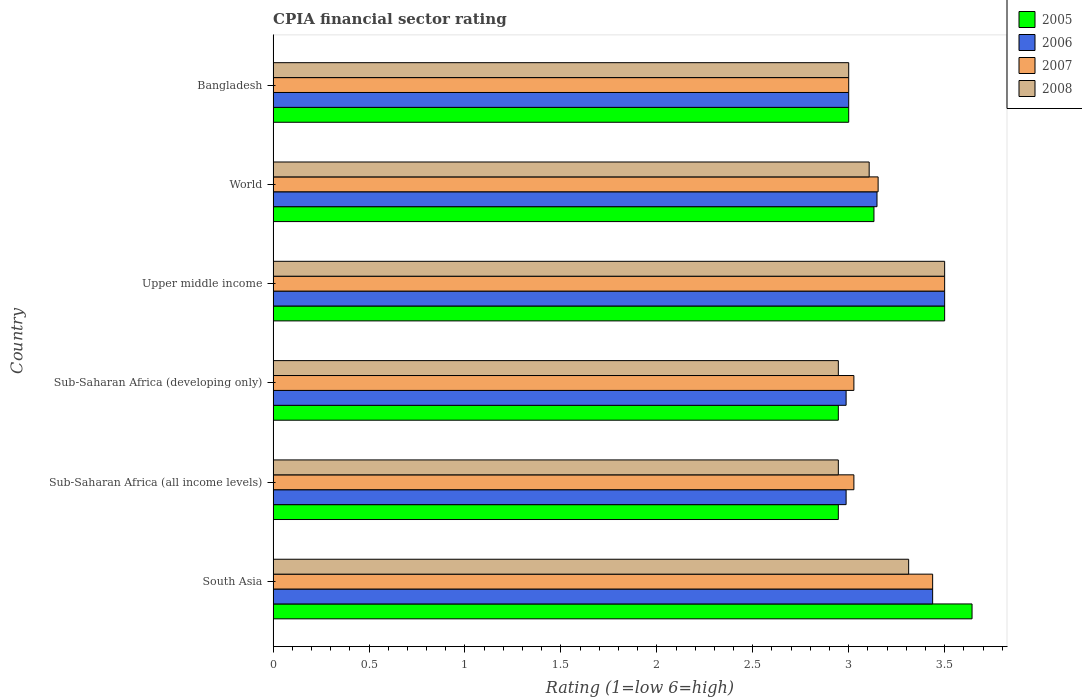How many different coloured bars are there?
Give a very brief answer. 4. How many groups of bars are there?
Your answer should be compact. 6. Are the number of bars per tick equal to the number of legend labels?
Give a very brief answer. Yes. Are the number of bars on each tick of the Y-axis equal?
Provide a succinct answer. Yes. How many bars are there on the 5th tick from the bottom?
Make the answer very short. 4. What is the label of the 5th group of bars from the top?
Ensure brevity in your answer.  Sub-Saharan Africa (all income levels). In how many cases, is the number of bars for a given country not equal to the number of legend labels?
Offer a terse response. 0. What is the CPIA rating in 2008 in Sub-Saharan Africa (all income levels)?
Offer a terse response. 2.95. Across all countries, what is the minimum CPIA rating in 2008?
Offer a very short reply. 2.95. In which country was the CPIA rating in 2008 minimum?
Provide a succinct answer. Sub-Saharan Africa (all income levels). What is the total CPIA rating in 2005 in the graph?
Make the answer very short. 19.17. What is the difference between the CPIA rating in 2005 in Upper middle income and that in World?
Give a very brief answer. 0.37. What is the difference between the CPIA rating in 2005 in Bangladesh and the CPIA rating in 2006 in World?
Make the answer very short. -0.15. What is the average CPIA rating in 2008 per country?
Give a very brief answer. 3.14. What is the difference between the CPIA rating in 2006 and CPIA rating in 2008 in Bangladesh?
Offer a terse response. 0. What is the ratio of the CPIA rating in 2008 in South Asia to that in Sub-Saharan Africa (developing only)?
Keep it short and to the point. 1.12. Is the CPIA rating in 2006 in South Asia less than that in World?
Provide a short and direct response. No. Is the difference between the CPIA rating in 2006 in Sub-Saharan Africa (developing only) and Upper middle income greater than the difference between the CPIA rating in 2008 in Sub-Saharan Africa (developing only) and Upper middle income?
Make the answer very short. Yes. What is the difference between the highest and the second highest CPIA rating in 2007?
Your answer should be compact. 0.06. What is the difference between the highest and the lowest CPIA rating in 2006?
Your answer should be compact. 0.51. In how many countries, is the CPIA rating in 2008 greater than the average CPIA rating in 2008 taken over all countries?
Provide a succinct answer. 2. Is the sum of the CPIA rating in 2006 in Sub-Saharan Africa (all income levels) and Upper middle income greater than the maximum CPIA rating in 2005 across all countries?
Your answer should be very brief. Yes. What does the 1st bar from the top in South Asia represents?
Provide a succinct answer. 2008. Is it the case that in every country, the sum of the CPIA rating in 2007 and CPIA rating in 2008 is greater than the CPIA rating in 2006?
Offer a very short reply. Yes. Are all the bars in the graph horizontal?
Ensure brevity in your answer.  Yes. What is the difference between two consecutive major ticks on the X-axis?
Your response must be concise. 0.5. Does the graph contain any zero values?
Provide a succinct answer. No. How are the legend labels stacked?
Ensure brevity in your answer.  Vertical. What is the title of the graph?
Ensure brevity in your answer.  CPIA financial sector rating. What is the label or title of the X-axis?
Provide a short and direct response. Rating (1=low 6=high). What is the Rating (1=low 6=high) of 2005 in South Asia?
Ensure brevity in your answer.  3.64. What is the Rating (1=low 6=high) of 2006 in South Asia?
Give a very brief answer. 3.44. What is the Rating (1=low 6=high) of 2007 in South Asia?
Your response must be concise. 3.44. What is the Rating (1=low 6=high) of 2008 in South Asia?
Make the answer very short. 3.31. What is the Rating (1=low 6=high) in 2005 in Sub-Saharan Africa (all income levels)?
Make the answer very short. 2.95. What is the Rating (1=low 6=high) of 2006 in Sub-Saharan Africa (all income levels)?
Your answer should be very brief. 2.99. What is the Rating (1=low 6=high) of 2007 in Sub-Saharan Africa (all income levels)?
Your answer should be compact. 3.03. What is the Rating (1=low 6=high) of 2008 in Sub-Saharan Africa (all income levels)?
Offer a terse response. 2.95. What is the Rating (1=low 6=high) in 2005 in Sub-Saharan Africa (developing only)?
Ensure brevity in your answer.  2.95. What is the Rating (1=low 6=high) in 2006 in Sub-Saharan Africa (developing only)?
Provide a succinct answer. 2.99. What is the Rating (1=low 6=high) in 2007 in Sub-Saharan Africa (developing only)?
Keep it short and to the point. 3.03. What is the Rating (1=low 6=high) in 2008 in Sub-Saharan Africa (developing only)?
Keep it short and to the point. 2.95. What is the Rating (1=low 6=high) of 2005 in World?
Your answer should be very brief. 3.13. What is the Rating (1=low 6=high) in 2006 in World?
Give a very brief answer. 3.15. What is the Rating (1=low 6=high) of 2007 in World?
Give a very brief answer. 3.15. What is the Rating (1=low 6=high) of 2008 in World?
Provide a short and direct response. 3.11. What is the Rating (1=low 6=high) of 2006 in Bangladesh?
Make the answer very short. 3. What is the Rating (1=low 6=high) of 2007 in Bangladesh?
Your response must be concise. 3. What is the Rating (1=low 6=high) in 2008 in Bangladesh?
Keep it short and to the point. 3. Across all countries, what is the maximum Rating (1=low 6=high) of 2005?
Give a very brief answer. 3.64. Across all countries, what is the maximum Rating (1=low 6=high) in 2008?
Offer a very short reply. 3.5. Across all countries, what is the minimum Rating (1=low 6=high) in 2005?
Provide a succinct answer. 2.95. Across all countries, what is the minimum Rating (1=low 6=high) of 2006?
Your response must be concise. 2.99. Across all countries, what is the minimum Rating (1=low 6=high) in 2008?
Give a very brief answer. 2.95. What is the total Rating (1=low 6=high) in 2005 in the graph?
Offer a terse response. 19.17. What is the total Rating (1=low 6=high) in 2006 in the graph?
Offer a very short reply. 19.06. What is the total Rating (1=low 6=high) of 2007 in the graph?
Your answer should be very brief. 19.14. What is the total Rating (1=low 6=high) in 2008 in the graph?
Provide a succinct answer. 18.81. What is the difference between the Rating (1=low 6=high) of 2005 in South Asia and that in Sub-Saharan Africa (all income levels)?
Your answer should be very brief. 0.7. What is the difference between the Rating (1=low 6=high) of 2006 in South Asia and that in Sub-Saharan Africa (all income levels)?
Offer a very short reply. 0.45. What is the difference between the Rating (1=low 6=high) of 2007 in South Asia and that in Sub-Saharan Africa (all income levels)?
Provide a succinct answer. 0.41. What is the difference between the Rating (1=low 6=high) in 2008 in South Asia and that in Sub-Saharan Africa (all income levels)?
Provide a short and direct response. 0.37. What is the difference between the Rating (1=low 6=high) of 2005 in South Asia and that in Sub-Saharan Africa (developing only)?
Provide a succinct answer. 0.7. What is the difference between the Rating (1=low 6=high) of 2006 in South Asia and that in Sub-Saharan Africa (developing only)?
Keep it short and to the point. 0.45. What is the difference between the Rating (1=low 6=high) in 2007 in South Asia and that in Sub-Saharan Africa (developing only)?
Your answer should be compact. 0.41. What is the difference between the Rating (1=low 6=high) in 2008 in South Asia and that in Sub-Saharan Africa (developing only)?
Your answer should be compact. 0.37. What is the difference between the Rating (1=low 6=high) of 2005 in South Asia and that in Upper middle income?
Offer a terse response. 0.14. What is the difference between the Rating (1=low 6=high) of 2006 in South Asia and that in Upper middle income?
Make the answer very short. -0.06. What is the difference between the Rating (1=low 6=high) in 2007 in South Asia and that in Upper middle income?
Provide a short and direct response. -0.06. What is the difference between the Rating (1=low 6=high) of 2008 in South Asia and that in Upper middle income?
Your answer should be compact. -0.19. What is the difference between the Rating (1=low 6=high) of 2005 in South Asia and that in World?
Keep it short and to the point. 0.51. What is the difference between the Rating (1=low 6=high) in 2006 in South Asia and that in World?
Ensure brevity in your answer.  0.29. What is the difference between the Rating (1=low 6=high) of 2007 in South Asia and that in World?
Your response must be concise. 0.28. What is the difference between the Rating (1=low 6=high) in 2008 in South Asia and that in World?
Ensure brevity in your answer.  0.21. What is the difference between the Rating (1=low 6=high) of 2005 in South Asia and that in Bangladesh?
Make the answer very short. 0.64. What is the difference between the Rating (1=low 6=high) in 2006 in South Asia and that in Bangladesh?
Your answer should be very brief. 0.44. What is the difference between the Rating (1=low 6=high) in 2007 in South Asia and that in Bangladesh?
Your answer should be compact. 0.44. What is the difference between the Rating (1=low 6=high) in 2008 in South Asia and that in Bangladesh?
Provide a succinct answer. 0.31. What is the difference between the Rating (1=low 6=high) of 2006 in Sub-Saharan Africa (all income levels) and that in Sub-Saharan Africa (developing only)?
Provide a succinct answer. 0. What is the difference between the Rating (1=low 6=high) of 2007 in Sub-Saharan Africa (all income levels) and that in Sub-Saharan Africa (developing only)?
Provide a short and direct response. 0. What is the difference between the Rating (1=low 6=high) in 2008 in Sub-Saharan Africa (all income levels) and that in Sub-Saharan Africa (developing only)?
Keep it short and to the point. 0. What is the difference between the Rating (1=low 6=high) in 2005 in Sub-Saharan Africa (all income levels) and that in Upper middle income?
Offer a terse response. -0.55. What is the difference between the Rating (1=low 6=high) in 2006 in Sub-Saharan Africa (all income levels) and that in Upper middle income?
Keep it short and to the point. -0.51. What is the difference between the Rating (1=low 6=high) in 2007 in Sub-Saharan Africa (all income levels) and that in Upper middle income?
Your answer should be compact. -0.47. What is the difference between the Rating (1=low 6=high) in 2008 in Sub-Saharan Africa (all income levels) and that in Upper middle income?
Make the answer very short. -0.55. What is the difference between the Rating (1=low 6=high) in 2005 in Sub-Saharan Africa (all income levels) and that in World?
Make the answer very short. -0.19. What is the difference between the Rating (1=low 6=high) of 2006 in Sub-Saharan Africa (all income levels) and that in World?
Your response must be concise. -0.16. What is the difference between the Rating (1=low 6=high) in 2007 in Sub-Saharan Africa (all income levels) and that in World?
Keep it short and to the point. -0.13. What is the difference between the Rating (1=low 6=high) of 2008 in Sub-Saharan Africa (all income levels) and that in World?
Your answer should be compact. -0.16. What is the difference between the Rating (1=low 6=high) in 2005 in Sub-Saharan Africa (all income levels) and that in Bangladesh?
Make the answer very short. -0.05. What is the difference between the Rating (1=low 6=high) in 2006 in Sub-Saharan Africa (all income levels) and that in Bangladesh?
Offer a very short reply. -0.01. What is the difference between the Rating (1=low 6=high) in 2007 in Sub-Saharan Africa (all income levels) and that in Bangladesh?
Keep it short and to the point. 0.03. What is the difference between the Rating (1=low 6=high) of 2008 in Sub-Saharan Africa (all income levels) and that in Bangladesh?
Ensure brevity in your answer.  -0.05. What is the difference between the Rating (1=low 6=high) of 2005 in Sub-Saharan Africa (developing only) and that in Upper middle income?
Offer a very short reply. -0.55. What is the difference between the Rating (1=low 6=high) in 2006 in Sub-Saharan Africa (developing only) and that in Upper middle income?
Provide a short and direct response. -0.51. What is the difference between the Rating (1=low 6=high) in 2007 in Sub-Saharan Africa (developing only) and that in Upper middle income?
Offer a very short reply. -0.47. What is the difference between the Rating (1=low 6=high) of 2008 in Sub-Saharan Africa (developing only) and that in Upper middle income?
Your answer should be compact. -0.55. What is the difference between the Rating (1=low 6=high) in 2005 in Sub-Saharan Africa (developing only) and that in World?
Your response must be concise. -0.19. What is the difference between the Rating (1=low 6=high) in 2006 in Sub-Saharan Africa (developing only) and that in World?
Keep it short and to the point. -0.16. What is the difference between the Rating (1=low 6=high) of 2007 in Sub-Saharan Africa (developing only) and that in World?
Your answer should be compact. -0.13. What is the difference between the Rating (1=low 6=high) of 2008 in Sub-Saharan Africa (developing only) and that in World?
Your response must be concise. -0.16. What is the difference between the Rating (1=low 6=high) of 2005 in Sub-Saharan Africa (developing only) and that in Bangladesh?
Give a very brief answer. -0.05. What is the difference between the Rating (1=low 6=high) of 2006 in Sub-Saharan Africa (developing only) and that in Bangladesh?
Offer a very short reply. -0.01. What is the difference between the Rating (1=low 6=high) in 2007 in Sub-Saharan Africa (developing only) and that in Bangladesh?
Your answer should be compact. 0.03. What is the difference between the Rating (1=low 6=high) in 2008 in Sub-Saharan Africa (developing only) and that in Bangladesh?
Provide a short and direct response. -0.05. What is the difference between the Rating (1=low 6=high) in 2005 in Upper middle income and that in World?
Offer a terse response. 0.37. What is the difference between the Rating (1=low 6=high) in 2006 in Upper middle income and that in World?
Give a very brief answer. 0.35. What is the difference between the Rating (1=low 6=high) in 2007 in Upper middle income and that in World?
Make the answer very short. 0.35. What is the difference between the Rating (1=low 6=high) in 2008 in Upper middle income and that in World?
Keep it short and to the point. 0.39. What is the difference between the Rating (1=low 6=high) in 2008 in Upper middle income and that in Bangladesh?
Give a very brief answer. 0.5. What is the difference between the Rating (1=low 6=high) in 2005 in World and that in Bangladesh?
Provide a short and direct response. 0.13. What is the difference between the Rating (1=low 6=high) in 2006 in World and that in Bangladesh?
Keep it short and to the point. 0.15. What is the difference between the Rating (1=low 6=high) of 2007 in World and that in Bangladesh?
Give a very brief answer. 0.15. What is the difference between the Rating (1=low 6=high) of 2008 in World and that in Bangladesh?
Provide a succinct answer. 0.11. What is the difference between the Rating (1=low 6=high) of 2005 in South Asia and the Rating (1=low 6=high) of 2006 in Sub-Saharan Africa (all income levels)?
Offer a very short reply. 0.66. What is the difference between the Rating (1=low 6=high) of 2005 in South Asia and the Rating (1=low 6=high) of 2007 in Sub-Saharan Africa (all income levels)?
Your answer should be very brief. 0.62. What is the difference between the Rating (1=low 6=high) of 2005 in South Asia and the Rating (1=low 6=high) of 2008 in Sub-Saharan Africa (all income levels)?
Keep it short and to the point. 0.7. What is the difference between the Rating (1=low 6=high) in 2006 in South Asia and the Rating (1=low 6=high) in 2007 in Sub-Saharan Africa (all income levels)?
Your answer should be very brief. 0.41. What is the difference between the Rating (1=low 6=high) in 2006 in South Asia and the Rating (1=low 6=high) in 2008 in Sub-Saharan Africa (all income levels)?
Offer a terse response. 0.49. What is the difference between the Rating (1=low 6=high) of 2007 in South Asia and the Rating (1=low 6=high) of 2008 in Sub-Saharan Africa (all income levels)?
Keep it short and to the point. 0.49. What is the difference between the Rating (1=low 6=high) of 2005 in South Asia and the Rating (1=low 6=high) of 2006 in Sub-Saharan Africa (developing only)?
Offer a terse response. 0.66. What is the difference between the Rating (1=low 6=high) in 2005 in South Asia and the Rating (1=low 6=high) in 2007 in Sub-Saharan Africa (developing only)?
Your answer should be very brief. 0.62. What is the difference between the Rating (1=low 6=high) in 2005 in South Asia and the Rating (1=low 6=high) in 2008 in Sub-Saharan Africa (developing only)?
Make the answer very short. 0.7. What is the difference between the Rating (1=low 6=high) in 2006 in South Asia and the Rating (1=low 6=high) in 2007 in Sub-Saharan Africa (developing only)?
Your response must be concise. 0.41. What is the difference between the Rating (1=low 6=high) in 2006 in South Asia and the Rating (1=low 6=high) in 2008 in Sub-Saharan Africa (developing only)?
Offer a terse response. 0.49. What is the difference between the Rating (1=low 6=high) of 2007 in South Asia and the Rating (1=low 6=high) of 2008 in Sub-Saharan Africa (developing only)?
Your response must be concise. 0.49. What is the difference between the Rating (1=low 6=high) of 2005 in South Asia and the Rating (1=low 6=high) of 2006 in Upper middle income?
Ensure brevity in your answer.  0.14. What is the difference between the Rating (1=low 6=high) in 2005 in South Asia and the Rating (1=low 6=high) in 2007 in Upper middle income?
Offer a terse response. 0.14. What is the difference between the Rating (1=low 6=high) in 2005 in South Asia and the Rating (1=low 6=high) in 2008 in Upper middle income?
Keep it short and to the point. 0.14. What is the difference between the Rating (1=low 6=high) in 2006 in South Asia and the Rating (1=low 6=high) in 2007 in Upper middle income?
Your response must be concise. -0.06. What is the difference between the Rating (1=low 6=high) in 2006 in South Asia and the Rating (1=low 6=high) in 2008 in Upper middle income?
Keep it short and to the point. -0.06. What is the difference between the Rating (1=low 6=high) in 2007 in South Asia and the Rating (1=low 6=high) in 2008 in Upper middle income?
Make the answer very short. -0.06. What is the difference between the Rating (1=low 6=high) in 2005 in South Asia and the Rating (1=low 6=high) in 2006 in World?
Keep it short and to the point. 0.5. What is the difference between the Rating (1=low 6=high) of 2005 in South Asia and the Rating (1=low 6=high) of 2007 in World?
Ensure brevity in your answer.  0.49. What is the difference between the Rating (1=low 6=high) of 2005 in South Asia and the Rating (1=low 6=high) of 2008 in World?
Keep it short and to the point. 0.54. What is the difference between the Rating (1=low 6=high) of 2006 in South Asia and the Rating (1=low 6=high) of 2007 in World?
Offer a very short reply. 0.28. What is the difference between the Rating (1=low 6=high) in 2006 in South Asia and the Rating (1=low 6=high) in 2008 in World?
Provide a short and direct response. 0.33. What is the difference between the Rating (1=low 6=high) in 2007 in South Asia and the Rating (1=low 6=high) in 2008 in World?
Keep it short and to the point. 0.33. What is the difference between the Rating (1=low 6=high) in 2005 in South Asia and the Rating (1=low 6=high) in 2006 in Bangladesh?
Offer a very short reply. 0.64. What is the difference between the Rating (1=low 6=high) in 2005 in South Asia and the Rating (1=low 6=high) in 2007 in Bangladesh?
Give a very brief answer. 0.64. What is the difference between the Rating (1=low 6=high) of 2005 in South Asia and the Rating (1=low 6=high) of 2008 in Bangladesh?
Your answer should be compact. 0.64. What is the difference between the Rating (1=low 6=high) of 2006 in South Asia and the Rating (1=low 6=high) of 2007 in Bangladesh?
Provide a succinct answer. 0.44. What is the difference between the Rating (1=low 6=high) of 2006 in South Asia and the Rating (1=low 6=high) of 2008 in Bangladesh?
Your answer should be compact. 0.44. What is the difference between the Rating (1=low 6=high) of 2007 in South Asia and the Rating (1=low 6=high) of 2008 in Bangladesh?
Offer a very short reply. 0.44. What is the difference between the Rating (1=low 6=high) in 2005 in Sub-Saharan Africa (all income levels) and the Rating (1=low 6=high) in 2006 in Sub-Saharan Africa (developing only)?
Offer a very short reply. -0.04. What is the difference between the Rating (1=low 6=high) in 2005 in Sub-Saharan Africa (all income levels) and the Rating (1=low 6=high) in 2007 in Sub-Saharan Africa (developing only)?
Keep it short and to the point. -0.08. What is the difference between the Rating (1=low 6=high) in 2006 in Sub-Saharan Africa (all income levels) and the Rating (1=low 6=high) in 2007 in Sub-Saharan Africa (developing only)?
Provide a short and direct response. -0.04. What is the difference between the Rating (1=low 6=high) of 2006 in Sub-Saharan Africa (all income levels) and the Rating (1=low 6=high) of 2008 in Sub-Saharan Africa (developing only)?
Make the answer very short. 0.04. What is the difference between the Rating (1=low 6=high) in 2007 in Sub-Saharan Africa (all income levels) and the Rating (1=low 6=high) in 2008 in Sub-Saharan Africa (developing only)?
Your answer should be very brief. 0.08. What is the difference between the Rating (1=low 6=high) in 2005 in Sub-Saharan Africa (all income levels) and the Rating (1=low 6=high) in 2006 in Upper middle income?
Provide a short and direct response. -0.55. What is the difference between the Rating (1=low 6=high) in 2005 in Sub-Saharan Africa (all income levels) and the Rating (1=low 6=high) in 2007 in Upper middle income?
Keep it short and to the point. -0.55. What is the difference between the Rating (1=low 6=high) in 2005 in Sub-Saharan Africa (all income levels) and the Rating (1=low 6=high) in 2008 in Upper middle income?
Provide a succinct answer. -0.55. What is the difference between the Rating (1=low 6=high) of 2006 in Sub-Saharan Africa (all income levels) and the Rating (1=low 6=high) of 2007 in Upper middle income?
Make the answer very short. -0.51. What is the difference between the Rating (1=low 6=high) of 2006 in Sub-Saharan Africa (all income levels) and the Rating (1=low 6=high) of 2008 in Upper middle income?
Keep it short and to the point. -0.51. What is the difference between the Rating (1=low 6=high) of 2007 in Sub-Saharan Africa (all income levels) and the Rating (1=low 6=high) of 2008 in Upper middle income?
Keep it short and to the point. -0.47. What is the difference between the Rating (1=low 6=high) in 2005 in Sub-Saharan Africa (all income levels) and the Rating (1=low 6=high) in 2006 in World?
Provide a succinct answer. -0.2. What is the difference between the Rating (1=low 6=high) in 2005 in Sub-Saharan Africa (all income levels) and the Rating (1=low 6=high) in 2007 in World?
Provide a succinct answer. -0.21. What is the difference between the Rating (1=low 6=high) in 2005 in Sub-Saharan Africa (all income levels) and the Rating (1=low 6=high) in 2008 in World?
Make the answer very short. -0.16. What is the difference between the Rating (1=low 6=high) in 2006 in Sub-Saharan Africa (all income levels) and the Rating (1=low 6=high) in 2007 in World?
Make the answer very short. -0.17. What is the difference between the Rating (1=low 6=high) of 2006 in Sub-Saharan Africa (all income levels) and the Rating (1=low 6=high) of 2008 in World?
Your answer should be compact. -0.12. What is the difference between the Rating (1=low 6=high) of 2007 in Sub-Saharan Africa (all income levels) and the Rating (1=low 6=high) of 2008 in World?
Make the answer very short. -0.08. What is the difference between the Rating (1=low 6=high) in 2005 in Sub-Saharan Africa (all income levels) and the Rating (1=low 6=high) in 2006 in Bangladesh?
Make the answer very short. -0.05. What is the difference between the Rating (1=low 6=high) in 2005 in Sub-Saharan Africa (all income levels) and the Rating (1=low 6=high) in 2007 in Bangladesh?
Offer a terse response. -0.05. What is the difference between the Rating (1=low 6=high) of 2005 in Sub-Saharan Africa (all income levels) and the Rating (1=low 6=high) of 2008 in Bangladesh?
Provide a succinct answer. -0.05. What is the difference between the Rating (1=low 6=high) of 2006 in Sub-Saharan Africa (all income levels) and the Rating (1=low 6=high) of 2007 in Bangladesh?
Provide a succinct answer. -0.01. What is the difference between the Rating (1=low 6=high) in 2006 in Sub-Saharan Africa (all income levels) and the Rating (1=low 6=high) in 2008 in Bangladesh?
Make the answer very short. -0.01. What is the difference between the Rating (1=low 6=high) of 2007 in Sub-Saharan Africa (all income levels) and the Rating (1=low 6=high) of 2008 in Bangladesh?
Keep it short and to the point. 0.03. What is the difference between the Rating (1=low 6=high) of 2005 in Sub-Saharan Africa (developing only) and the Rating (1=low 6=high) of 2006 in Upper middle income?
Provide a short and direct response. -0.55. What is the difference between the Rating (1=low 6=high) of 2005 in Sub-Saharan Africa (developing only) and the Rating (1=low 6=high) of 2007 in Upper middle income?
Offer a very short reply. -0.55. What is the difference between the Rating (1=low 6=high) of 2005 in Sub-Saharan Africa (developing only) and the Rating (1=low 6=high) of 2008 in Upper middle income?
Your answer should be very brief. -0.55. What is the difference between the Rating (1=low 6=high) in 2006 in Sub-Saharan Africa (developing only) and the Rating (1=low 6=high) in 2007 in Upper middle income?
Make the answer very short. -0.51. What is the difference between the Rating (1=low 6=high) in 2006 in Sub-Saharan Africa (developing only) and the Rating (1=low 6=high) in 2008 in Upper middle income?
Ensure brevity in your answer.  -0.51. What is the difference between the Rating (1=low 6=high) of 2007 in Sub-Saharan Africa (developing only) and the Rating (1=low 6=high) of 2008 in Upper middle income?
Your answer should be very brief. -0.47. What is the difference between the Rating (1=low 6=high) in 2005 in Sub-Saharan Africa (developing only) and the Rating (1=low 6=high) in 2006 in World?
Your answer should be very brief. -0.2. What is the difference between the Rating (1=low 6=high) of 2005 in Sub-Saharan Africa (developing only) and the Rating (1=low 6=high) of 2007 in World?
Offer a terse response. -0.21. What is the difference between the Rating (1=low 6=high) of 2005 in Sub-Saharan Africa (developing only) and the Rating (1=low 6=high) of 2008 in World?
Offer a very short reply. -0.16. What is the difference between the Rating (1=low 6=high) in 2006 in Sub-Saharan Africa (developing only) and the Rating (1=low 6=high) in 2007 in World?
Make the answer very short. -0.17. What is the difference between the Rating (1=low 6=high) in 2006 in Sub-Saharan Africa (developing only) and the Rating (1=low 6=high) in 2008 in World?
Offer a terse response. -0.12. What is the difference between the Rating (1=low 6=high) in 2007 in Sub-Saharan Africa (developing only) and the Rating (1=low 6=high) in 2008 in World?
Give a very brief answer. -0.08. What is the difference between the Rating (1=low 6=high) in 2005 in Sub-Saharan Africa (developing only) and the Rating (1=low 6=high) in 2006 in Bangladesh?
Your response must be concise. -0.05. What is the difference between the Rating (1=low 6=high) in 2005 in Sub-Saharan Africa (developing only) and the Rating (1=low 6=high) in 2007 in Bangladesh?
Your answer should be very brief. -0.05. What is the difference between the Rating (1=low 6=high) of 2005 in Sub-Saharan Africa (developing only) and the Rating (1=low 6=high) of 2008 in Bangladesh?
Keep it short and to the point. -0.05. What is the difference between the Rating (1=low 6=high) of 2006 in Sub-Saharan Africa (developing only) and the Rating (1=low 6=high) of 2007 in Bangladesh?
Your answer should be very brief. -0.01. What is the difference between the Rating (1=low 6=high) in 2006 in Sub-Saharan Africa (developing only) and the Rating (1=low 6=high) in 2008 in Bangladesh?
Your answer should be very brief. -0.01. What is the difference between the Rating (1=low 6=high) of 2007 in Sub-Saharan Africa (developing only) and the Rating (1=low 6=high) of 2008 in Bangladesh?
Keep it short and to the point. 0.03. What is the difference between the Rating (1=low 6=high) of 2005 in Upper middle income and the Rating (1=low 6=high) of 2006 in World?
Ensure brevity in your answer.  0.35. What is the difference between the Rating (1=low 6=high) in 2005 in Upper middle income and the Rating (1=low 6=high) in 2007 in World?
Keep it short and to the point. 0.35. What is the difference between the Rating (1=low 6=high) in 2005 in Upper middle income and the Rating (1=low 6=high) in 2008 in World?
Your response must be concise. 0.39. What is the difference between the Rating (1=low 6=high) in 2006 in Upper middle income and the Rating (1=low 6=high) in 2007 in World?
Your answer should be compact. 0.35. What is the difference between the Rating (1=low 6=high) in 2006 in Upper middle income and the Rating (1=low 6=high) in 2008 in World?
Ensure brevity in your answer.  0.39. What is the difference between the Rating (1=low 6=high) of 2007 in Upper middle income and the Rating (1=low 6=high) of 2008 in World?
Give a very brief answer. 0.39. What is the difference between the Rating (1=low 6=high) in 2005 in Upper middle income and the Rating (1=low 6=high) in 2007 in Bangladesh?
Make the answer very short. 0.5. What is the difference between the Rating (1=low 6=high) in 2007 in Upper middle income and the Rating (1=low 6=high) in 2008 in Bangladesh?
Offer a very short reply. 0.5. What is the difference between the Rating (1=low 6=high) in 2005 in World and the Rating (1=low 6=high) in 2006 in Bangladesh?
Provide a succinct answer. 0.13. What is the difference between the Rating (1=low 6=high) in 2005 in World and the Rating (1=low 6=high) in 2007 in Bangladesh?
Ensure brevity in your answer.  0.13. What is the difference between the Rating (1=low 6=high) of 2005 in World and the Rating (1=low 6=high) of 2008 in Bangladesh?
Ensure brevity in your answer.  0.13. What is the difference between the Rating (1=low 6=high) of 2006 in World and the Rating (1=low 6=high) of 2007 in Bangladesh?
Your response must be concise. 0.15. What is the difference between the Rating (1=low 6=high) in 2006 in World and the Rating (1=low 6=high) in 2008 in Bangladesh?
Offer a very short reply. 0.15. What is the difference between the Rating (1=low 6=high) of 2007 in World and the Rating (1=low 6=high) of 2008 in Bangladesh?
Offer a terse response. 0.15. What is the average Rating (1=low 6=high) in 2005 per country?
Give a very brief answer. 3.19. What is the average Rating (1=low 6=high) of 2006 per country?
Ensure brevity in your answer.  3.18. What is the average Rating (1=low 6=high) of 2007 per country?
Give a very brief answer. 3.19. What is the average Rating (1=low 6=high) in 2008 per country?
Offer a terse response. 3.14. What is the difference between the Rating (1=low 6=high) of 2005 and Rating (1=low 6=high) of 2006 in South Asia?
Your response must be concise. 0.21. What is the difference between the Rating (1=low 6=high) of 2005 and Rating (1=low 6=high) of 2007 in South Asia?
Offer a very short reply. 0.21. What is the difference between the Rating (1=low 6=high) in 2005 and Rating (1=low 6=high) in 2008 in South Asia?
Offer a terse response. 0.33. What is the difference between the Rating (1=low 6=high) in 2006 and Rating (1=low 6=high) in 2008 in South Asia?
Your answer should be compact. 0.12. What is the difference between the Rating (1=low 6=high) in 2007 and Rating (1=low 6=high) in 2008 in South Asia?
Your answer should be compact. 0.12. What is the difference between the Rating (1=low 6=high) in 2005 and Rating (1=low 6=high) in 2006 in Sub-Saharan Africa (all income levels)?
Ensure brevity in your answer.  -0.04. What is the difference between the Rating (1=low 6=high) of 2005 and Rating (1=low 6=high) of 2007 in Sub-Saharan Africa (all income levels)?
Offer a very short reply. -0.08. What is the difference between the Rating (1=low 6=high) in 2006 and Rating (1=low 6=high) in 2007 in Sub-Saharan Africa (all income levels)?
Your response must be concise. -0.04. What is the difference between the Rating (1=low 6=high) of 2006 and Rating (1=low 6=high) of 2008 in Sub-Saharan Africa (all income levels)?
Your answer should be compact. 0.04. What is the difference between the Rating (1=low 6=high) of 2007 and Rating (1=low 6=high) of 2008 in Sub-Saharan Africa (all income levels)?
Ensure brevity in your answer.  0.08. What is the difference between the Rating (1=low 6=high) of 2005 and Rating (1=low 6=high) of 2006 in Sub-Saharan Africa (developing only)?
Ensure brevity in your answer.  -0.04. What is the difference between the Rating (1=low 6=high) in 2005 and Rating (1=low 6=high) in 2007 in Sub-Saharan Africa (developing only)?
Keep it short and to the point. -0.08. What is the difference between the Rating (1=low 6=high) in 2005 and Rating (1=low 6=high) in 2008 in Sub-Saharan Africa (developing only)?
Make the answer very short. 0. What is the difference between the Rating (1=low 6=high) in 2006 and Rating (1=low 6=high) in 2007 in Sub-Saharan Africa (developing only)?
Your answer should be compact. -0.04. What is the difference between the Rating (1=low 6=high) of 2006 and Rating (1=low 6=high) of 2008 in Sub-Saharan Africa (developing only)?
Provide a succinct answer. 0.04. What is the difference between the Rating (1=low 6=high) in 2007 and Rating (1=low 6=high) in 2008 in Sub-Saharan Africa (developing only)?
Your answer should be compact. 0.08. What is the difference between the Rating (1=low 6=high) of 2006 and Rating (1=low 6=high) of 2008 in Upper middle income?
Keep it short and to the point. 0. What is the difference between the Rating (1=low 6=high) of 2007 and Rating (1=low 6=high) of 2008 in Upper middle income?
Your answer should be compact. 0. What is the difference between the Rating (1=low 6=high) in 2005 and Rating (1=low 6=high) in 2006 in World?
Your answer should be very brief. -0.02. What is the difference between the Rating (1=low 6=high) in 2005 and Rating (1=low 6=high) in 2007 in World?
Give a very brief answer. -0.02. What is the difference between the Rating (1=low 6=high) of 2005 and Rating (1=low 6=high) of 2008 in World?
Ensure brevity in your answer.  0.02. What is the difference between the Rating (1=low 6=high) of 2006 and Rating (1=low 6=high) of 2007 in World?
Your answer should be compact. -0.01. What is the difference between the Rating (1=low 6=high) in 2006 and Rating (1=low 6=high) in 2008 in World?
Your response must be concise. 0.04. What is the difference between the Rating (1=low 6=high) in 2007 and Rating (1=low 6=high) in 2008 in World?
Keep it short and to the point. 0.05. What is the difference between the Rating (1=low 6=high) in 2005 and Rating (1=low 6=high) in 2007 in Bangladesh?
Your answer should be compact. 0. What is the difference between the Rating (1=low 6=high) of 2005 and Rating (1=low 6=high) of 2008 in Bangladesh?
Offer a very short reply. 0. What is the difference between the Rating (1=low 6=high) of 2007 and Rating (1=low 6=high) of 2008 in Bangladesh?
Give a very brief answer. 0. What is the ratio of the Rating (1=low 6=high) in 2005 in South Asia to that in Sub-Saharan Africa (all income levels)?
Offer a very short reply. 1.24. What is the ratio of the Rating (1=low 6=high) in 2006 in South Asia to that in Sub-Saharan Africa (all income levels)?
Offer a very short reply. 1.15. What is the ratio of the Rating (1=low 6=high) of 2007 in South Asia to that in Sub-Saharan Africa (all income levels)?
Provide a short and direct response. 1.14. What is the ratio of the Rating (1=low 6=high) in 2008 in South Asia to that in Sub-Saharan Africa (all income levels)?
Offer a terse response. 1.12. What is the ratio of the Rating (1=low 6=high) in 2005 in South Asia to that in Sub-Saharan Africa (developing only)?
Your answer should be very brief. 1.24. What is the ratio of the Rating (1=low 6=high) in 2006 in South Asia to that in Sub-Saharan Africa (developing only)?
Keep it short and to the point. 1.15. What is the ratio of the Rating (1=low 6=high) of 2007 in South Asia to that in Sub-Saharan Africa (developing only)?
Offer a terse response. 1.14. What is the ratio of the Rating (1=low 6=high) of 2008 in South Asia to that in Sub-Saharan Africa (developing only)?
Your answer should be very brief. 1.12. What is the ratio of the Rating (1=low 6=high) in 2005 in South Asia to that in Upper middle income?
Offer a terse response. 1.04. What is the ratio of the Rating (1=low 6=high) of 2006 in South Asia to that in Upper middle income?
Offer a very short reply. 0.98. What is the ratio of the Rating (1=low 6=high) in 2007 in South Asia to that in Upper middle income?
Your answer should be very brief. 0.98. What is the ratio of the Rating (1=low 6=high) in 2008 in South Asia to that in Upper middle income?
Your answer should be compact. 0.95. What is the ratio of the Rating (1=low 6=high) in 2005 in South Asia to that in World?
Provide a short and direct response. 1.16. What is the ratio of the Rating (1=low 6=high) in 2006 in South Asia to that in World?
Give a very brief answer. 1.09. What is the ratio of the Rating (1=low 6=high) of 2007 in South Asia to that in World?
Give a very brief answer. 1.09. What is the ratio of the Rating (1=low 6=high) in 2008 in South Asia to that in World?
Provide a short and direct response. 1.07. What is the ratio of the Rating (1=low 6=high) in 2005 in South Asia to that in Bangladesh?
Ensure brevity in your answer.  1.21. What is the ratio of the Rating (1=low 6=high) of 2006 in South Asia to that in Bangladesh?
Your response must be concise. 1.15. What is the ratio of the Rating (1=low 6=high) in 2007 in South Asia to that in Bangladesh?
Make the answer very short. 1.15. What is the ratio of the Rating (1=low 6=high) of 2008 in South Asia to that in Bangladesh?
Keep it short and to the point. 1.1. What is the ratio of the Rating (1=low 6=high) in 2005 in Sub-Saharan Africa (all income levels) to that in Upper middle income?
Your answer should be very brief. 0.84. What is the ratio of the Rating (1=low 6=high) of 2006 in Sub-Saharan Africa (all income levels) to that in Upper middle income?
Provide a succinct answer. 0.85. What is the ratio of the Rating (1=low 6=high) in 2007 in Sub-Saharan Africa (all income levels) to that in Upper middle income?
Give a very brief answer. 0.86. What is the ratio of the Rating (1=low 6=high) in 2008 in Sub-Saharan Africa (all income levels) to that in Upper middle income?
Provide a succinct answer. 0.84. What is the ratio of the Rating (1=low 6=high) of 2005 in Sub-Saharan Africa (all income levels) to that in World?
Provide a short and direct response. 0.94. What is the ratio of the Rating (1=low 6=high) of 2006 in Sub-Saharan Africa (all income levels) to that in World?
Your response must be concise. 0.95. What is the ratio of the Rating (1=low 6=high) in 2007 in Sub-Saharan Africa (all income levels) to that in World?
Your answer should be compact. 0.96. What is the ratio of the Rating (1=low 6=high) in 2008 in Sub-Saharan Africa (all income levels) to that in World?
Your response must be concise. 0.95. What is the ratio of the Rating (1=low 6=high) in 2005 in Sub-Saharan Africa (all income levels) to that in Bangladesh?
Offer a terse response. 0.98. What is the ratio of the Rating (1=low 6=high) of 2007 in Sub-Saharan Africa (all income levels) to that in Bangladesh?
Your answer should be very brief. 1.01. What is the ratio of the Rating (1=low 6=high) in 2008 in Sub-Saharan Africa (all income levels) to that in Bangladesh?
Give a very brief answer. 0.98. What is the ratio of the Rating (1=low 6=high) in 2005 in Sub-Saharan Africa (developing only) to that in Upper middle income?
Offer a very short reply. 0.84. What is the ratio of the Rating (1=low 6=high) of 2006 in Sub-Saharan Africa (developing only) to that in Upper middle income?
Offer a very short reply. 0.85. What is the ratio of the Rating (1=low 6=high) in 2007 in Sub-Saharan Africa (developing only) to that in Upper middle income?
Ensure brevity in your answer.  0.86. What is the ratio of the Rating (1=low 6=high) of 2008 in Sub-Saharan Africa (developing only) to that in Upper middle income?
Your response must be concise. 0.84. What is the ratio of the Rating (1=low 6=high) of 2005 in Sub-Saharan Africa (developing only) to that in World?
Your response must be concise. 0.94. What is the ratio of the Rating (1=low 6=high) in 2006 in Sub-Saharan Africa (developing only) to that in World?
Offer a terse response. 0.95. What is the ratio of the Rating (1=low 6=high) in 2007 in Sub-Saharan Africa (developing only) to that in World?
Provide a short and direct response. 0.96. What is the ratio of the Rating (1=low 6=high) of 2008 in Sub-Saharan Africa (developing only) to that in World?
Your answer should be very brief. 0.95. What is the ratio of the Rating (1=low 6=high) of 2005 in Sub-Saharan Africa (developing only) to that in Bangladesh?
Make the answer very short. 0.98. What is the ratio of the Rating (1=low 6=high) of 2006 in Sub-Saharan Africa (developing only) to that in Bangladesh?
Your answer should be very brief. 1. What is the ratio of the Rating (1=low 6=high) of 2007 in Sub-Saharan Africa (developing only) to that in Bangladesh?
Ensure brevity in your answer.  1.01. What is the ratio of the Rating (1=low 6=high) in 2008 in Sub-Saharan Africa (developing only) to that in Bangladesh?
Your answer should be compact. 0.98. What is the ratio of the Rating (1=low 6=high) of 2005 in Upper middle income to that in World?
Keep it short and to the point. 1.12. What is the ratio of the Rating (1=low 6=high) of 2006 in Upper middle income to that in World?
Offer a terse response. 1.11. What is the ratio of the Rating (1=low 6=high) of 2007 in Upper middle income to that in World?
Provide a succinct answer. 1.11. What is the ratio of the Rating (1=low 6=high) in 2008 in Upper middle income to that in World?
Make the answer very short. 1.13. What is the ratio of the Rating (1=low 6=high) in 2006 in Upper middle income to that in Bangladesh?
Keep it short and to the point. 1.17. What is the ratio of the Rating (1=low 6=high) in 2007 in Upper middle income to that in Bangladesh?
Your answer should be compact. 1.17. What is the ratio of the Rating (1=low 6=high) in 2008 in Upper middle income to that in Bangladesh?
Provide a succinct answer. 1.17. What is the ratio of the Rating (1=low 6=high) of 2005 in World to that in Bangladesh?
Keep it short and to the point. 1.04. What is the ratio of the Rating (1=low 6=high) in 2006 in World to that in Bangladesh?
Your response must be concise. 1.05. What is the ratio of the Rating (1=low 6=high) of 2007 in World to that in Bangladesh?
Your response must be concise. 1.05. What is the ratio of the Rating (1=low 6=high) of 2008 in World to that in Bangladesh?
Your answer should be compact. 1.04. What is the difference between the highest and the second highest Rating (1=low 6=high) in 2005?
Offer a very short reply. 0.14. What is the difference between the highest and the second highest Rating (1=low 6=high) of 2006?
Make the answer very short. 0.06. What is the difference between the highest and the second highest Rating (1=low 6=high) in 2007?
Your answer should be very brief. 0.06. What is the difference between the highest and the second highest Rating (1=low 6=high) of 2008?
Your answer should be compact. 0.19. What is the difference between the highest and the lowest Rating (1=low 6=high) in 2005?
Offer a very short reply. 0.7. What is the difference between the highest and the lowest Rating (1=low 6=high) of 2006?
Offer a very short reply. 0.51. What is the difference between the highest and the lowest Rating (1=low 6=high) of 2008?
Give a very brief answer. 0.55. 